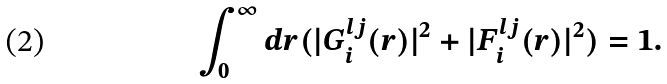<formula> <loc_0><loc_0><loc_500><loc_500>\int _ { 0 } ^ { \infty } d r ( | G _ { i } ^ { l j } ( r ) | ^ { 2 } + | F _ { i } ^ { l j } ( r ) | ^ { 2 } ) = 1 .</formula> 